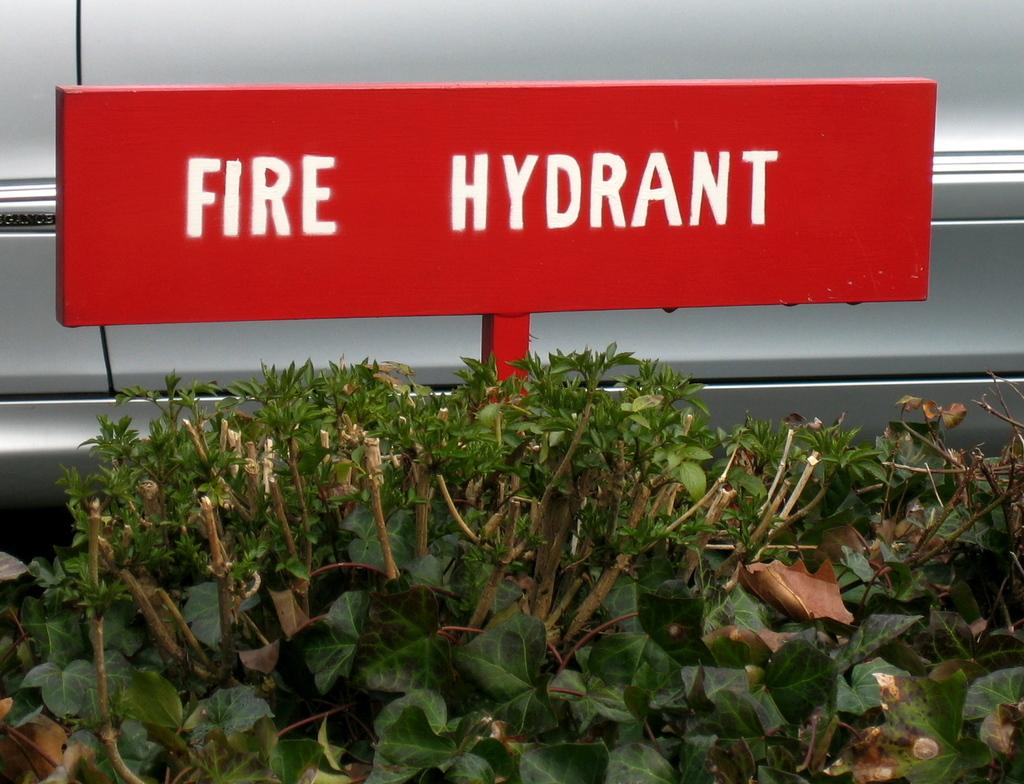What type of living organisms can be seen in the image? Plants can be seen in the image. What is the color of the board in the image? The board in the image is red. What words are written on the board? The board has the words "fire hydrant" written on it. Can you see a wren using a comb on the baby in the image? There is no wren, comb, or baby present in the image. 